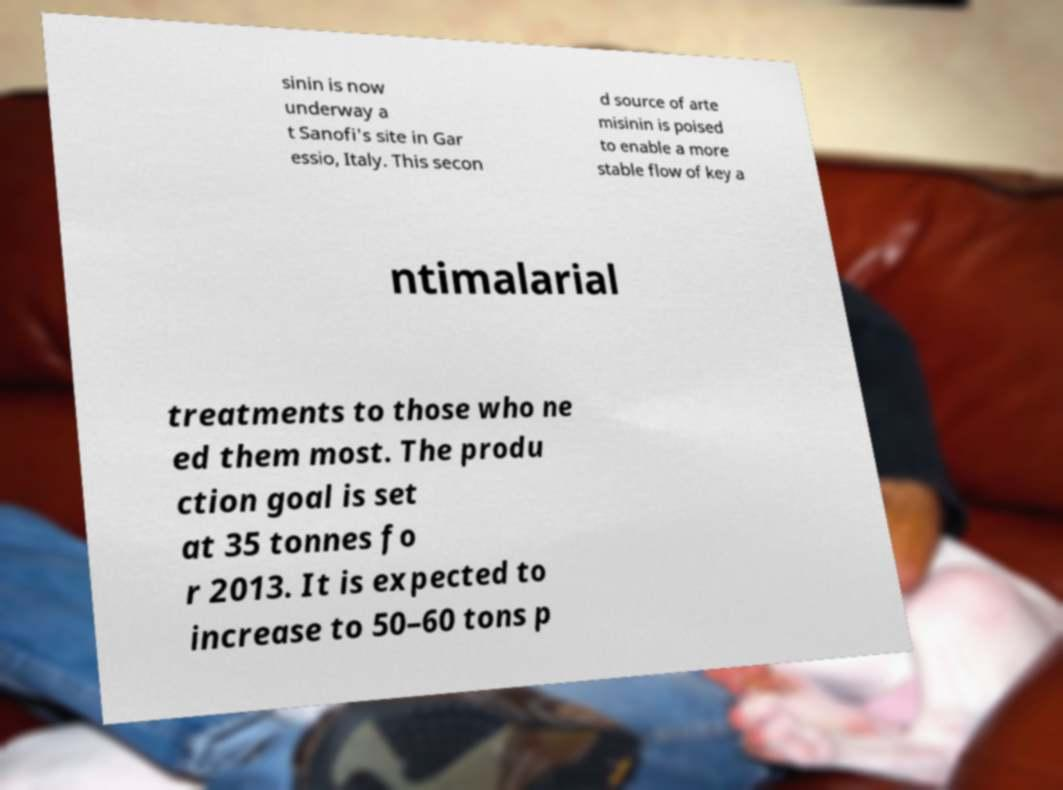Please read and relay the text visible in this image. What does it say? sinin is now underway a t Sanofi's site in Gar essio, Italy. This secon d source of arte misinin is poised to enable a more stable flow of key a ntimalarial treatments to those who ne ed them most. The produ ction goal is set at 35 tonnes fo r 2013. It is expected to increase to 50–60 tons p 